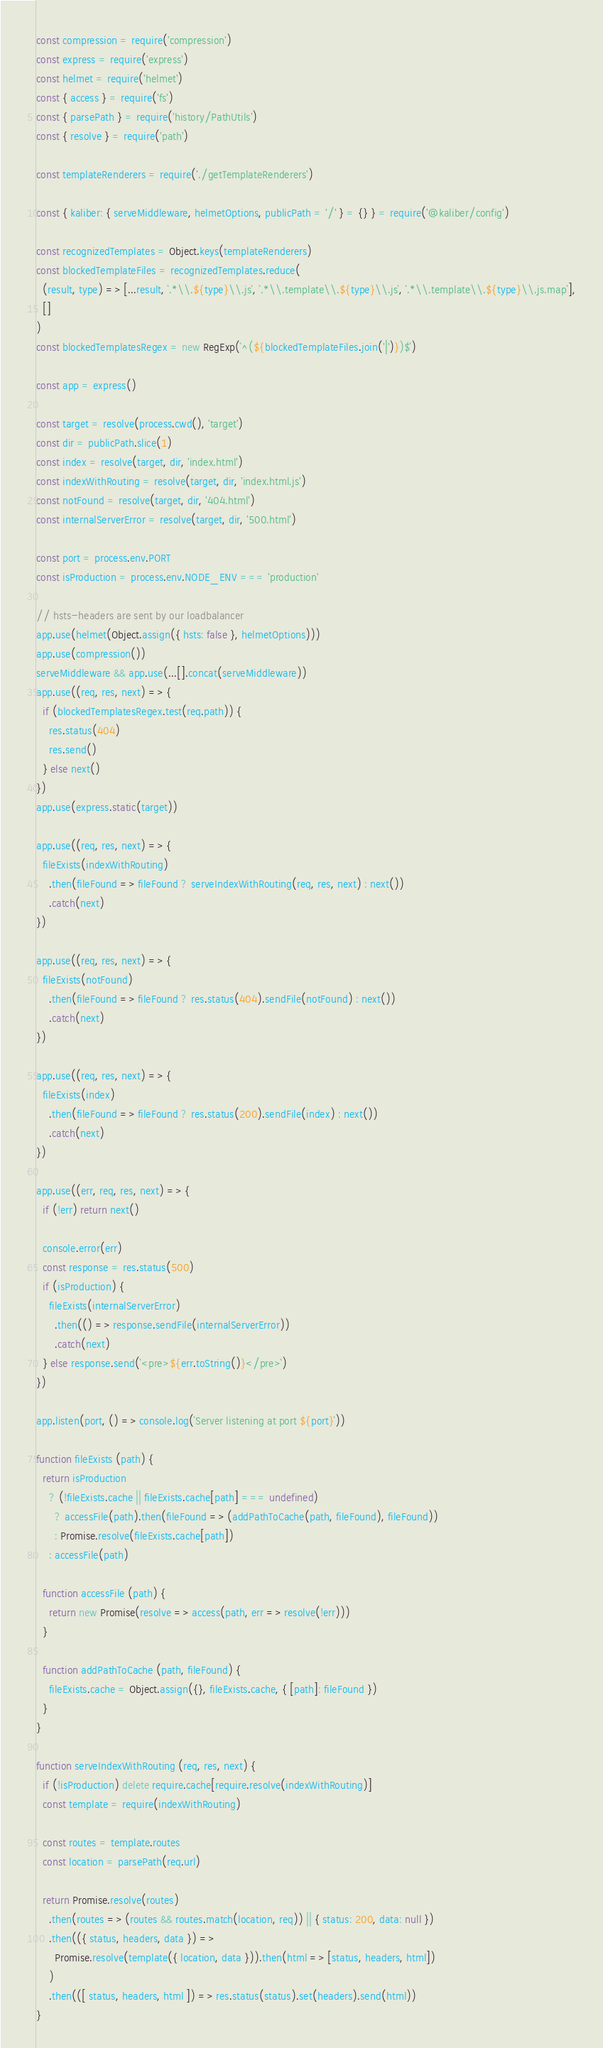<code> <loc_0><loc_0><loc_500><loc_500><_JavaScript_>const compression = require('compression')
const express = require('express')
const helmet = require('helmet')
const { access } = require('fs')
const { parsePath } = require('history/PathUtils')
const { resolve } = require('path')

const templateRenderers = require('./getTemplateRenderers')

const { kaliber: { serveMiddleware, helmetOptions, publicPath = '/' } = {} } = require('@kaliber/config')

const recognizedTemplates = Object.keys(templateRenderers)
const blockedTemplateFiles = recognizedTemplates.reduce(
  (result, type) => [...result, `.*\\.${type}\\.js`, `.*\\.template\\.${type}\\.js`, `.*\\.template\\.${type}\\.js.map`],
  []
)
const blockedTemplatesRegex = new RegExp(`^(${blockedTemplateFiles.join('|')})$`)

const app = express()

const target = resolve(process.cwd(), 'target')
const dir = publicPath.slice(1)
const index = resolve(target, dir, 'index.html')
const indexWithRouting = resolve(target, dir, 'index.html.js')
const notFound = resolve(target, dir, '404.html')
const internalServerError = resolve(target, dir, '500.html')

const port = process.env.PORT
const isProduction = process.env.NODE_ENV === 'production'

// hsts-headers are sent by our loadbalancer
app.use(helmet(Object.assign({ hsts: false }, helmetOptions)))
app.use(compression())
serveMiddleware && app.use(...[].concat(serveMiddleware))
app.use((req, res, next) => {
  if (blockedTemplatesRegex.test(req.path)) {
    res.status(404)
    res.send()
  } else next()
})
app.use(express.static(target))

app.use((req, res, next) => {
  fileExists(indexWithRouting)
    .then(fileFound => fileFound ? serveIndexWithRouting(req, res, next) : next())
    .catch(next)
})

app.use((req, res, next) => {
  fileExists(notFound)
    .then(fileFound => fileFound ? res.status(404).sendFile(notFound) : next())
    .catch(next)
})

app.use((req, res, next) => {
  fileExists(index)
    .then(fileFound => fileFound ? res.status(200).sendFile(index) : next())
    .catch(next)
})

app.use((err, req, res, next) => {
  if (!err) return next()

  console.error(err)
  const response = res.status(500)
  if (isProduction) {
    fileExists(internalServerError)
      .then(() => response.sendFile(internalServerError))
      .catch(next)
  } else response.send(`<pre>${err.toString()}</pre>`)
})

app.listen(port, () => console.log(`Server listening at port ${port}`))

function fileExists (path) {
  return isProduction
    ? (!fileExists.cache || fileExists.cache[path] === undefined)
      ? accessFile(path).then(fileFound => (addPathToCache(path, fileFound), fileFound))
      : Promise.resolve(fileExists.cache[path])
    : accessFile(path)

  function accessFile (path) {
    return new Promise(resolve => access(path, err => resolve(!err)))
  }

  function addPathToCache (path, fileFound) {
    fileExists.cache = Object.assign({}, fileExists.cache, { [path]: fileFound })
  }
}

function serveIndexWithRouting (req, res, next) {
  if (!isProduction) delete require.cache[require.resolve(indexWithRouting)]
  const template = require(indexWithRouting)

  const routes = template.routes
  const location = parsePath(req.url)

  return Promise.resolve(routes)
    .then(routes => (routes && routes.match(location, req)) || { status: 200, data: null })
    .then(({ status, headers, data }) =>
      Promise.resolve(template({ location, data })).then(html => [status, headers, html])
    )
    .then(([ status, headers, html ]) => res.status(status).set(headers).send(html))
}
</code> 